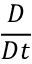Convert formula to latex. <formula><loc_0><loc_0><loc_500><loc_500>\frac { D } { D t }</formula> 